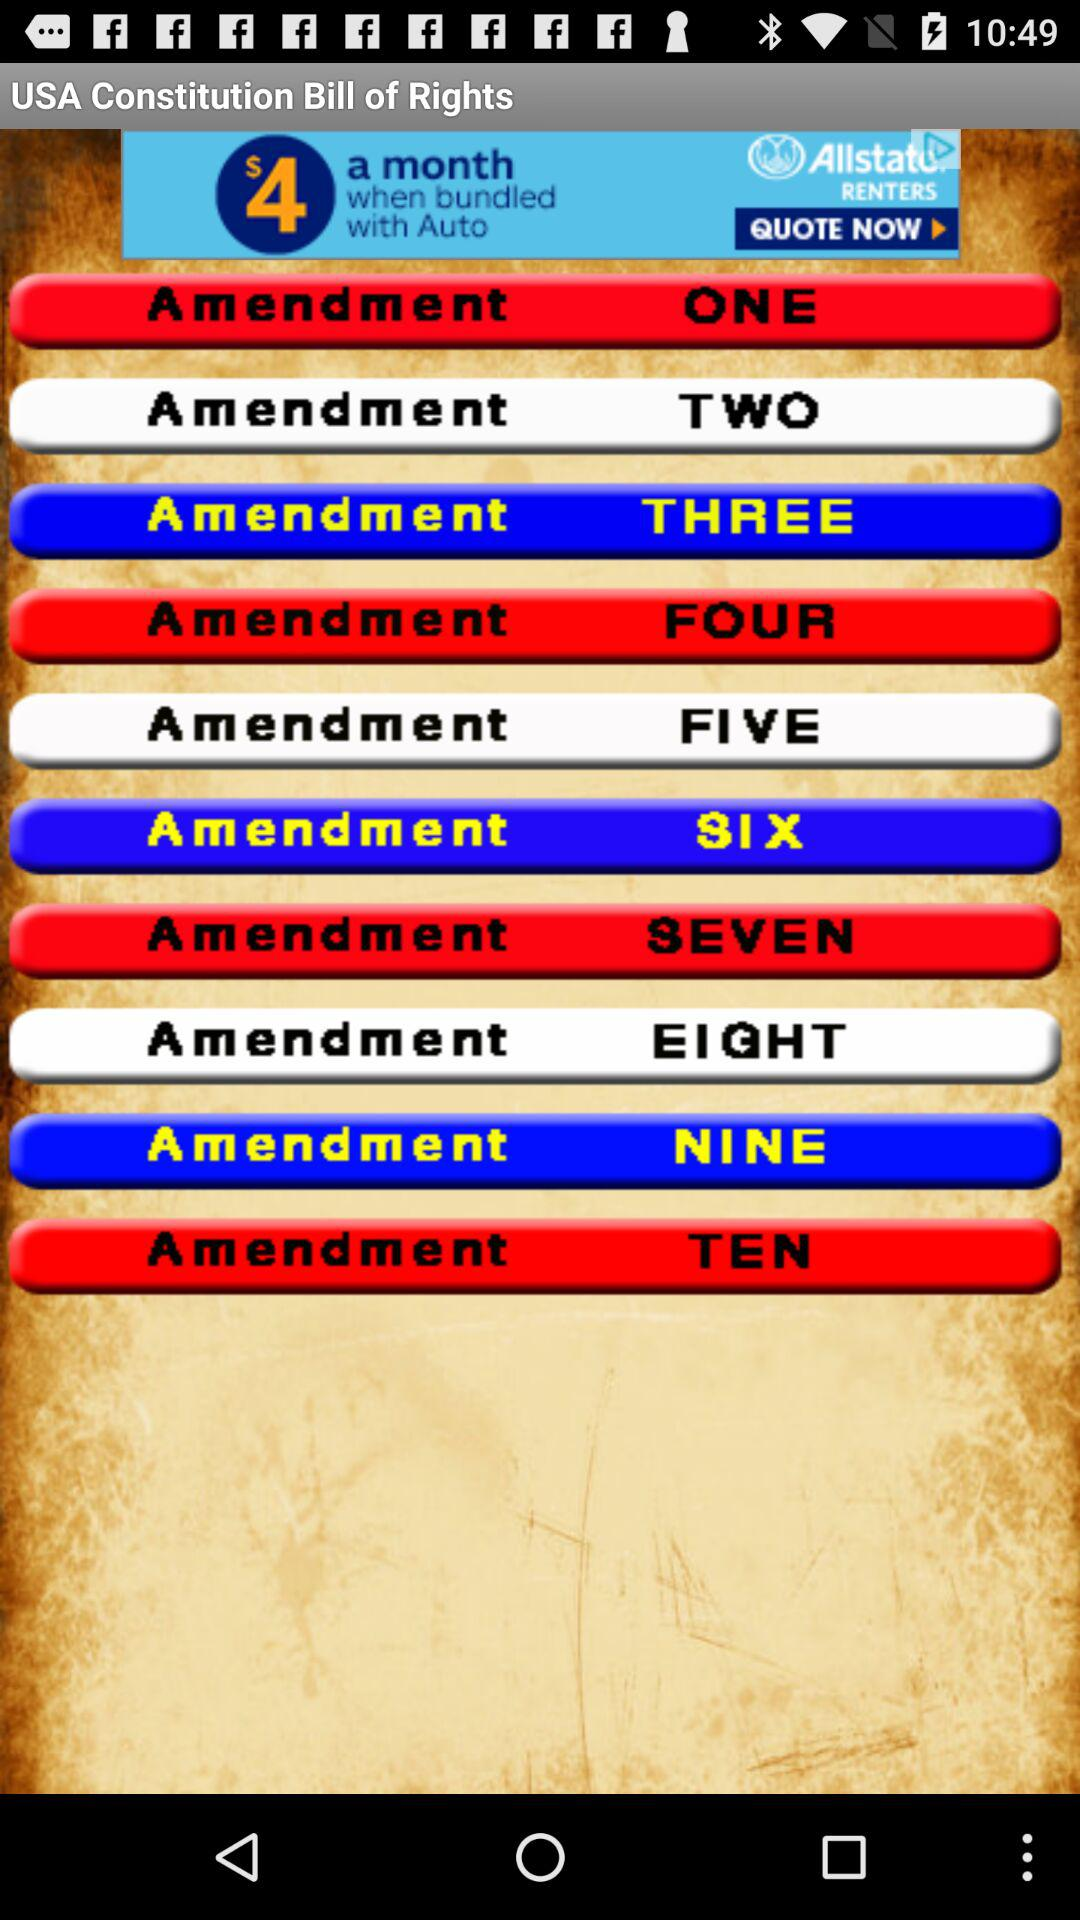How many amendments are there in total?
Answer the question using a single word or phrase. 10 